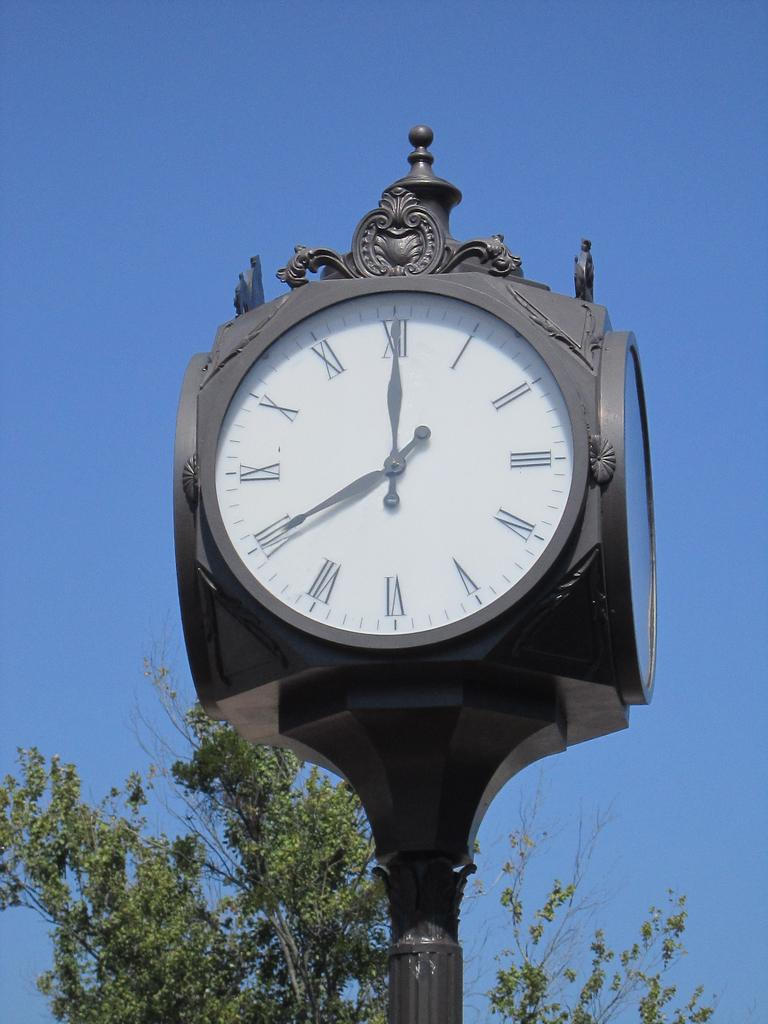<image>
Create a compact narrative representing the image presented. An ornate clock tells us it is 11:40 beneath a cloudless sky. 